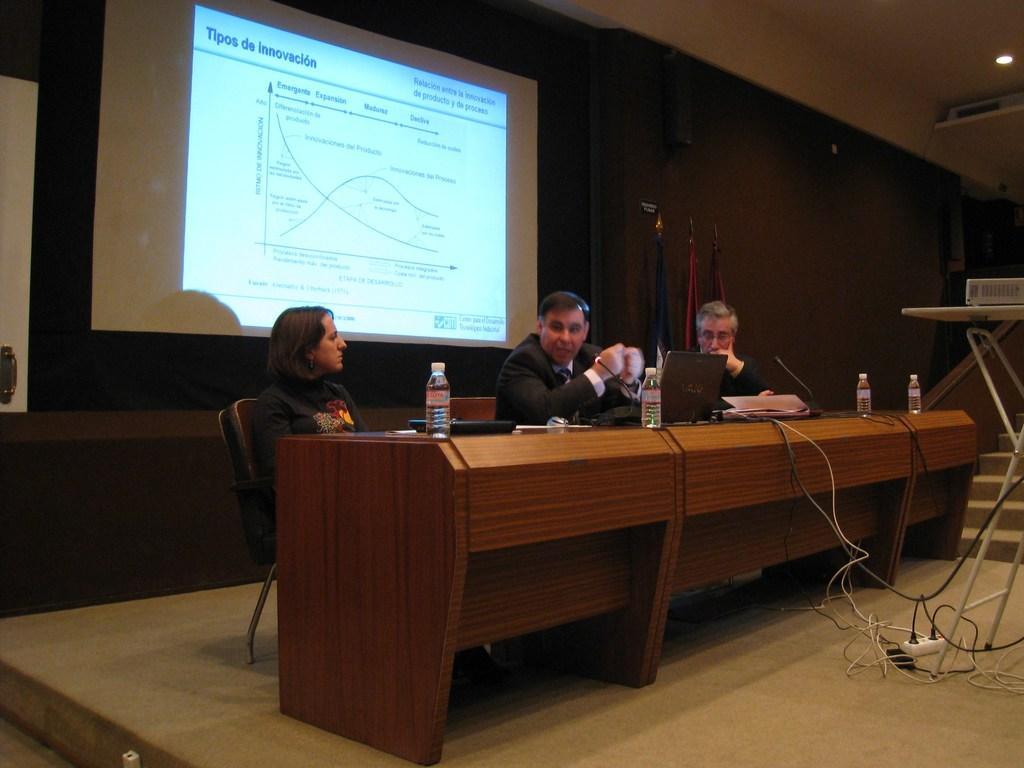Describe this image in one or two sentences. In the image we can see there are people who are sitting on chair and at the back there is a screen. 